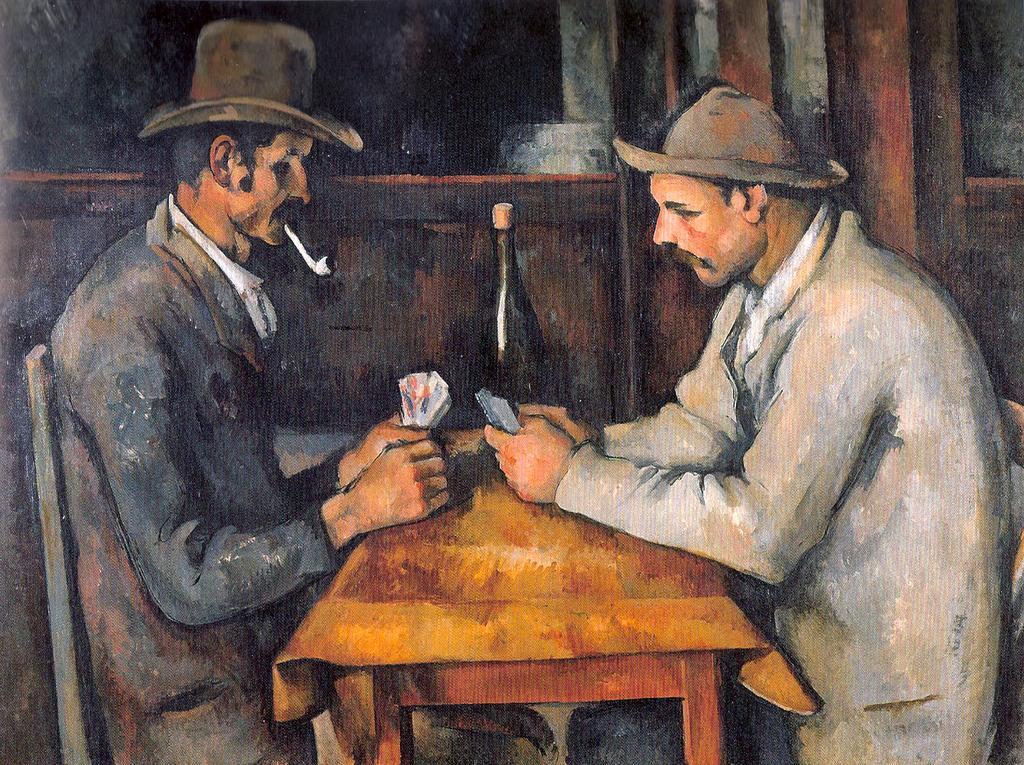How would you summarize this image in a sentence or two? This is a painting. In this image we can see two persons sitting at the table and playing cards. In the background there is a bottle and wall. 